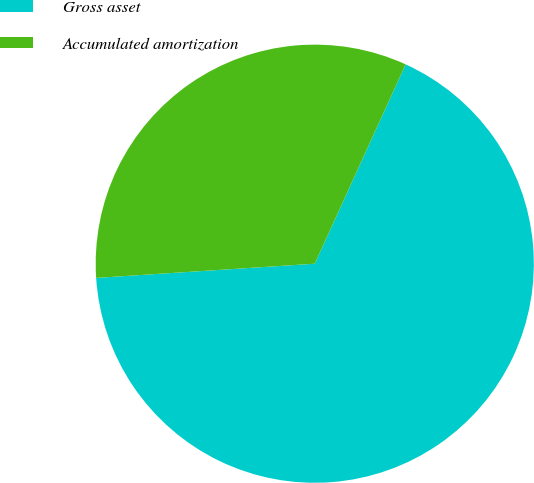Convert chart. <chart><loc_0><loc_0><loc_500><loc_500><pie_chart><fcel>Gross asset<fcel>Accumulated amortization<nl><fcel>67.16%<fcel>32.84%<nl></chart> 